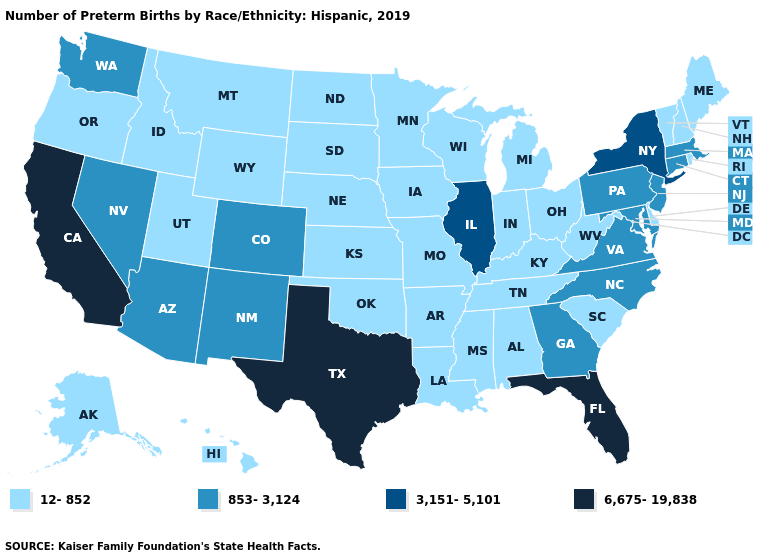Which states have the lowest value in the West?
Be succinct. Alaska, Hawaii, Idaho, Montana, Oregon, Utah, Wyoming. What is the value of Minnesota?
Write a very short answer. 12-852. Name the states that have a value in the range 6,675-19,838?
Answer briefly. California, Florida, Texas. Does Texas have the highest value in the South?
Answer briefly. Yes. Name the states that have a value in the range 853-3,124?
Keep it brief. Arizona, Colorado, Connecticut, Georgia, Maryland, Massachusetts, Nevada, New Jersey, New Mexico, North Carolina, Pennsylvania, Virginia, Washington. Which states have the lowest value in the USA?
Concise answer only. Alabama, Alaska, Arkansas, Delaware, Hawaii, Idaho, Indiana, Iowa, Kansas, Kentucky, Louisiana, Maine, Michigan, Minnesota, Mississippi, Missouri, Montana, Nebraska, New Hampshire, North Dakota, Ohio, Oklahoma, Oregon, Rhode Island, South Carolina, South Dakota, Tennessee, Utah, Vermont, West Virginia, Wisconsin, Wyoming. Does the map have missing data?
Keep it brief. No. How many symbols are there in the legend?
Concise answer only. 4. What is the highest value in the MidWest ?
Write a very short answer. 3,151-5,101. Does the first symbol in the legend represent the smallest category?
Concise answer only. Yes. Name the states that have a value in the range 3,151-5,101?
Keep it brief. Illinois, New York. Which states hav the highest value in the Northeast?
Write a very short answer. New York. Which states have the highest value in the USA?
Write a very short answer. California, Florida, Texas. Does Oklahoma have a lower value than Delaware?
Write a very short answer. No. What is the highest value in states that border Arkansas?
Answer briefly. 6,675-19,838. 